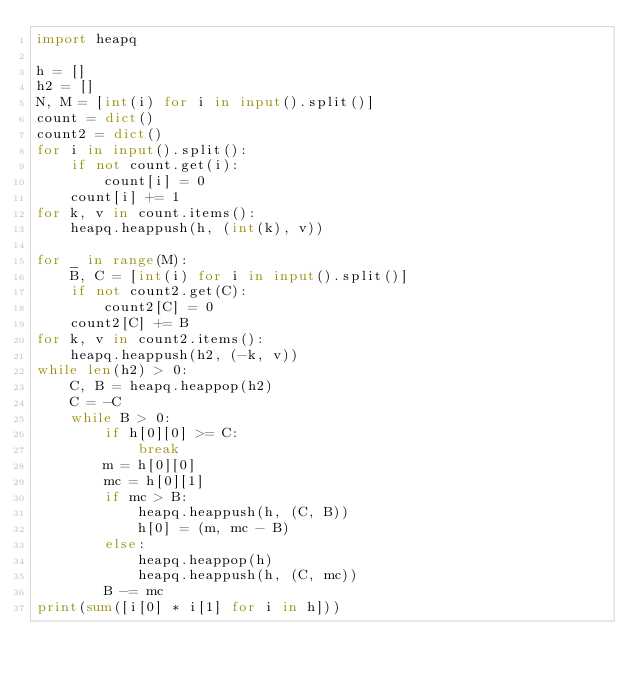Convert code to text. <code><loc_0><loc_0><loc_500><loc_500><_Python_>import heapq

h = []
h2 = []
N, M = [int(i) for i in input().split()]
count = dict()
count2 = dict()
for i in input().split():
    if not count.get(i):
        count[i] = 0
    count[i] += 1
for k, v in count.items():
    heapq.heappush(h, (int(k), v))

for _ in range(M):
    B, C = [int(i) for i in input().split()]
    if not count2.get(C):
        count2[C] = 0
    count2[C] += B
for k, v in count2.items():
    heapq.heappush(h2, (-k, v))
while len(h2) > 0:
    C, B = heapq.heappop(h2)
    C = -C
    while B > 0:
        if h[0][0] >= C:
            break
        m = h[0][0]
        mc = h[0][1]
        if mc > B:
            heapq.heappush(h, (C, B))
            h[0] = (m, mc - B)
        else:
            heapq.heappop(h)
            heapq.heappush(h, (C, mc))
        B -= mc
print(sum([i[0] * i[1] for i in h]))

</code> 